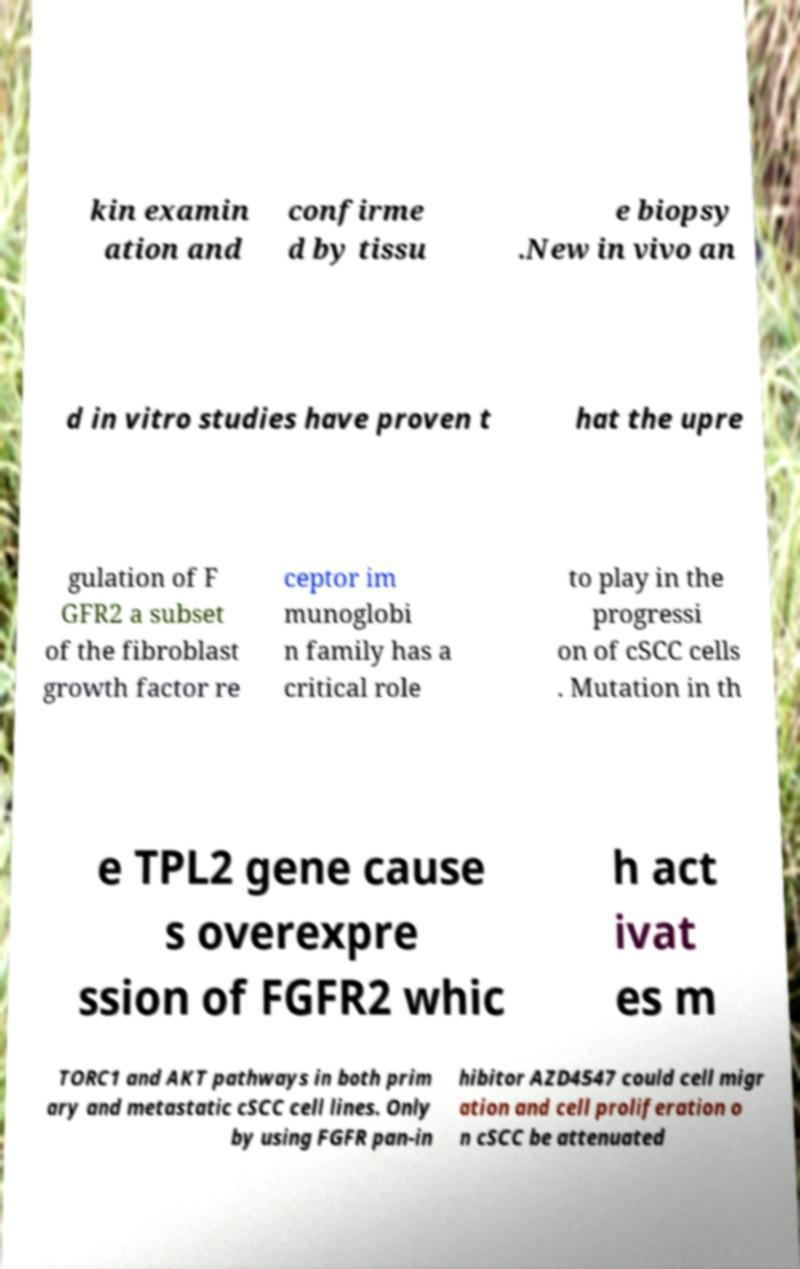Could you extract and type out the text from this image? kin examin ation and confirme d by tissu e biopsy .New in vivo an d in vitro studies have proven t hat the upre gulation of F GFR2 a subset of the fibroblast growth factor re ceptor im munoglobi n family has a critical role to play in the progressi on of cSCC cells . Mutation in th e TPL2 gene cause s overexpre ssion of FGFR2 whic h act ivat es m TORC1 and AKT pathways in both prim ary and metastatic cSCC cell lines. Only by using FGFR pan-in hibitor AZD4547 could cell migr ation and cell proliferation o n cSCC be attenuated 